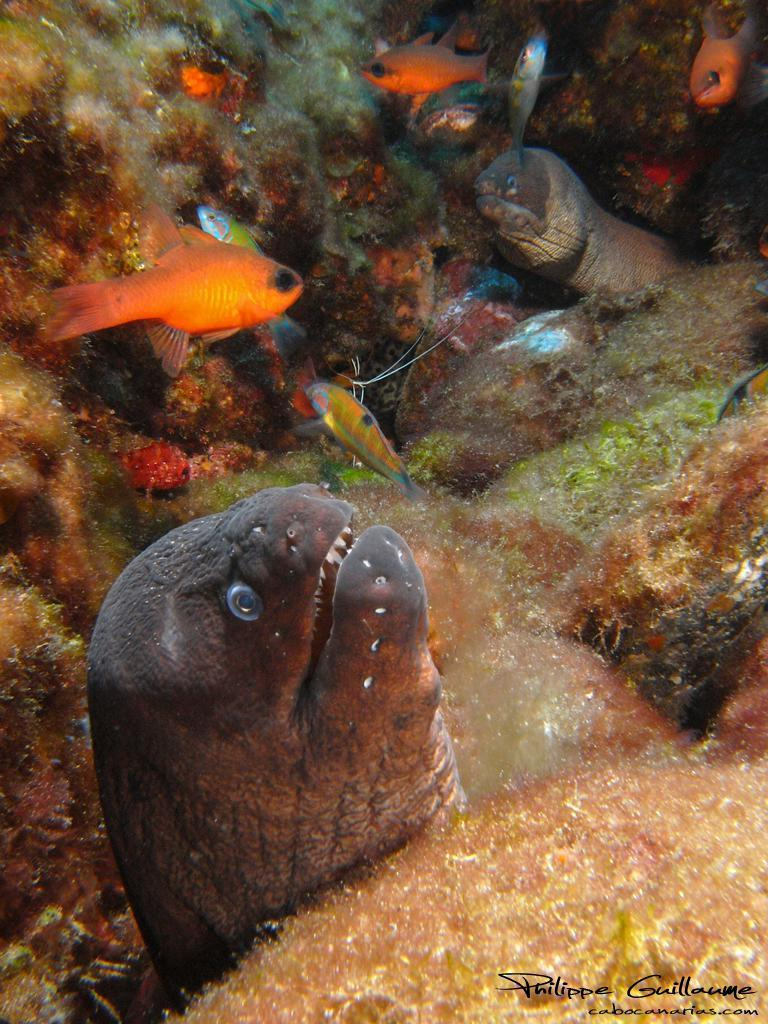What type of animals can be seen in the water in the image? There are colorful fishes in the water in the image. What other objects or elements can be seen in the image? There are rocks in the image. What type of skin condition can be seen on the fishes in the image? There is no indication of any skin condition on the fishes in the image, as they appear to be healthy and colorful. 